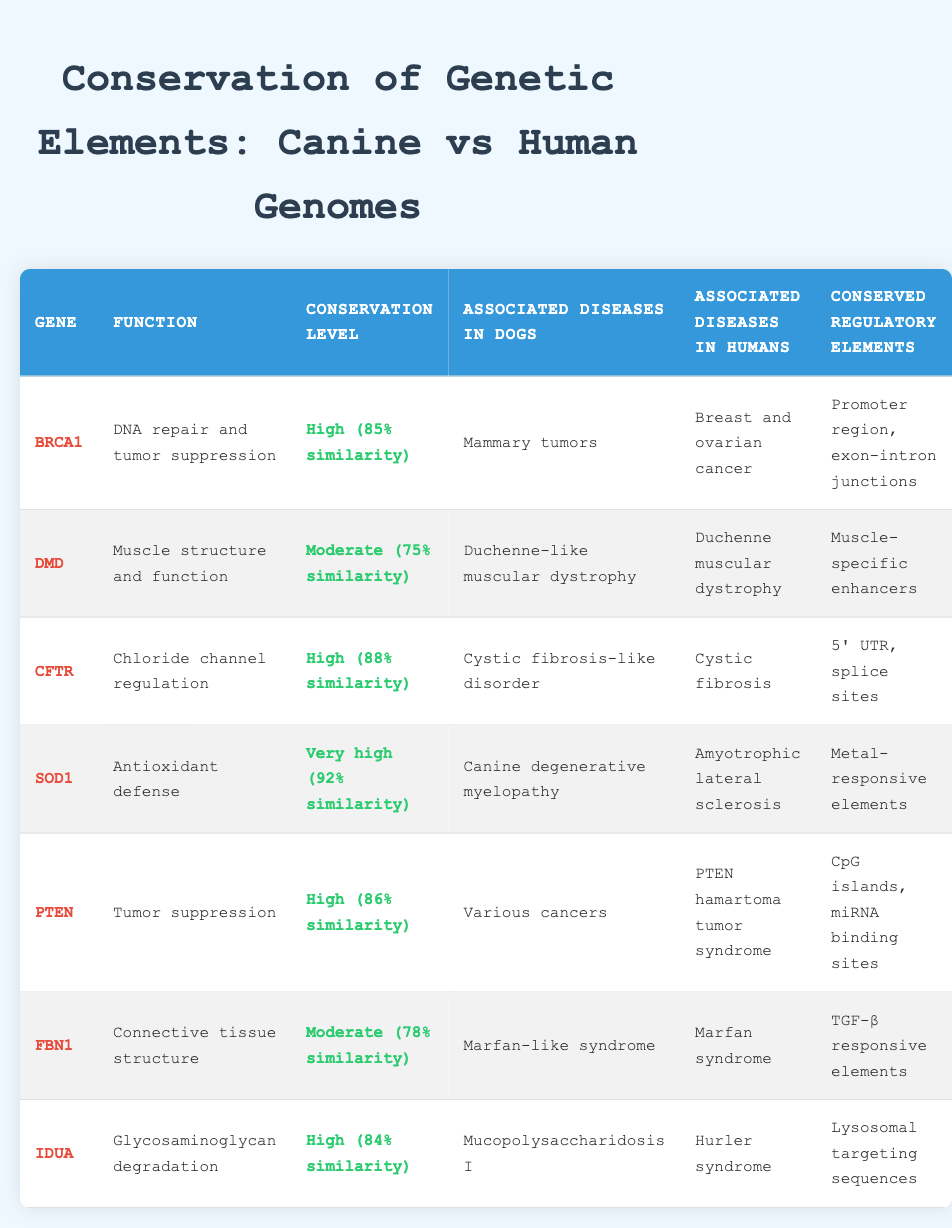What is the conservation level of the BRCA1 gene? The table lists the conservation level of the BRCA1 gene under the "Conservation Level" column, which states it is "High (85% similarity)."
Answer: High (85% similarity) How many genes have a very high conservation level? From the table, I can see that SOD1 is the only gene marked with "Very high (92% similarity)" in the conservation level column, making it one gene.
Answer: 1 Do dogs associate the DMD gene with Duchenne muscular dystrophy? According to the table, the DMD gene is associated with "Duchenne-like muscular dystrophy" in dogs, so the association is not direct but related. The answer is therefore no.
Answer: No Which gene has the highest similarity in terms of conservation level? In the table, the conservation levels are compared, and SOD1 has a very high conservation level of "92% similarity," which is the highest among all listed genes.
Answer: SOD1 What is the average conservation level of the genes associated with tumors? The conservation levels for tumor-associated genes BRCA1, PTEN, and SOD1 are High (85), High (86), and Very high (92), respectively. The average of these similarity percentages is calculated as (85 + 86 + 92) / 3 = 87.67, so the average conservation level is 87.67.
Answer: 87.67 Is there a gene with a moderate conservation level linked to Marfan syndrome? The table shows that FBN1 is associated with Marfan syndrome and has a conservation level of "Moderate (78% similarity)." This confirms the presence of such a gene.
Answer: Yes Which gene has the highest conservation level and what diseases does it relate to? Reviewing the table, SOD1 has the highest conservation level of "Very high (92% similarity)." It is associated with "Canine degenerative myelopathy" in dogs and "Amyotrophic lateral sclerosis" in humans.
Answer: SOD1, Canine degenerative myelopathy, Amyotrophic lateral sclerosis How does the conservation level of IDUA compare to the others? The conservation level of IDUA is "High (84% similarity)." When compared to others, it ranks in the middle, being lower than SOD1, CFTR, PTEN, and BRCA1 but higher than DMD and FBN1 on the list.
Answer: Middle-range (High - 84% similarity) 